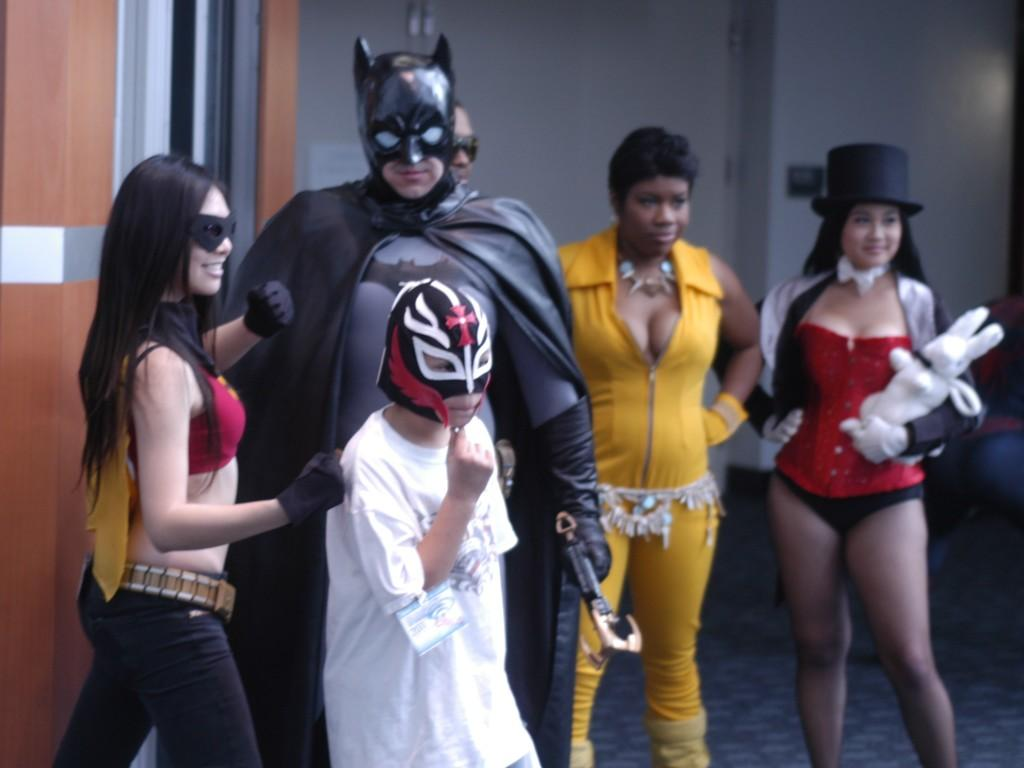How many people are in the image? There are people in the image, but the exact number is not specified. What are the people wearing in the image? The people are wearing costumes in the image. What type of volleyball game is being played by the people in the image? There is no indication of a volleyball game or any sports activity in the image. Can you tell me how many crows are visible in the image? There is no mention of crows in the image; it features people wearing costumes. What is the kitty doing in the image? There is no kitty present in the image. 